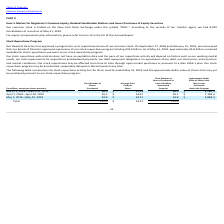Looking at Oracle Corporation's financial data, please calculate: What is the average approximate Dollar Value of Shares that May Yet Be Purchased Under the Program from March 1, 2019 to May 31, 2019? To answer this question, I need to perform calculations using the financial data. The calculation is: (8,780.5+7,198.4+5,848.4) / 3 , which equals 7275.77 (in millions). This is based on the information: "May 1, 2019—May 31, 2019 24.9 $ 54.11 24.9 $ 5,848.4 March 1, 2019—March 31, 2019 58.0 $ 52.93 58.0 $ 8,780.5 April 1, 2019—April 30, 2019 29.1 $ 54.41 29.1 $ 7,198.4..." The key data points involved are: 5,848.4, 7,198.4, 8,780.5. Also, can you calculate: How much is the percentage decrease in total number of shares purchased from March 2019 to April 2019? To answer this question, I need to perform calculations using the financial data. The calculation is: (29.1-58.0)/58.0 , which equals -49.83 (percentage). This is based on the information: "April 1, 2019—April 30, 2019 29.1 $ 54.41 29.1 $ 7,198.4 March 1, 2019—March 31, 2019 58.0 $ 52.93 58.0 $ 8,780.5..." The key data points involved are: 29.1, 58.0. Also, can you calculate: What was the Average Price Paid per Share from March 2019 to April 2019? To answer this question, I need to perform calculations using the financial data. The calculation is: (52.93*58.0+54.41*29.1)/(58.0+29.1) , which equals 53.42. This is based on the information: "April 1, 2019—April 30, 2019 29.1 $ 54.41 29.1 $ 7,198.4 March 1, 2019—March 31, 2019 58.0 $ 52.93 58.0 $ 8,780.5 March 1, 2019—March 31, 2019 58.0 $ 52.93 58.0 $ 8,780.5 April 1, 2019—April 30, 2019 ..." The key data points involved are: 29.1, 52.93, 54.41. Also, What factors could potentially affect the pace of Oracle’s stock repurchase activities? Our stock repurchase authorization does not have an expiration date and the pace of our repurchase activity will depend on factors such as our working capital needs, our cash requirements for acquisitions and dividend payments, our debt repayment obligations or repurchases of our debt, our stock price, and economic and market conditions.. The document states: "Our stock repurchase authorization does not have an expiration date and the pace of our repurchase activity will depend on factors such as our working..." Also, When did Oracle announce the approval of expansions of the stock repurchase program by the Board of Directors? On September 17, 2018 and February 15, 2019, we announced that our Board of Directors approved expansions of our stock repurchase program totaling $24.0 billion.. The document states: "m for us to repurchase shares of our common stock. On September 17, 2018 and February 15, 2019, we announced that our Board of Directors approved expa..." Also, How does Oracle effect its stock repurchases? Our stock repurchases may be effected from time to time through open market purchases or pursuant to a rule 10b5-1 plan. Our stock repurchase program may be accelerated, suspended, delayed or discontinued at any time.. The document states: "r stock price, and economic and market conditions. Our stock repurchases may be effected from time to time through open market purchases or pursuant t..." 